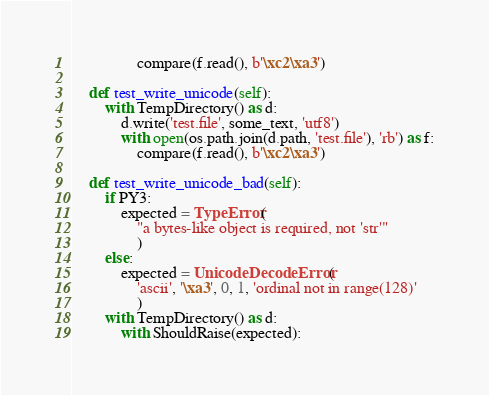<code> <loc_0><loc_0><loc_500><loc_500><_Python_>                compare(f.read(), b'\xc2\xa3')

    def test_write_unicode(self):
        with TempDirectory() as d:
            d.write('test.file', some_text, 'utf8')
            with open(os.path.join(d.path, 'test.file'), 'rb') as f:
                compare(f.read(), b'\xc2\xa3')

    def test_write_unicode_bad(self):
        if PY3:
            expected = TypeError(
                "a bytes-like object is required, not 'str'"
                )
        else:
            expected = UnicodeDecodeError(
                'ascii', '\xa3', 0, 1, 'ordinal not in range(128)'
                )
        with TempDirectory() as d:
            with ShouldRaise(expected):</code> 